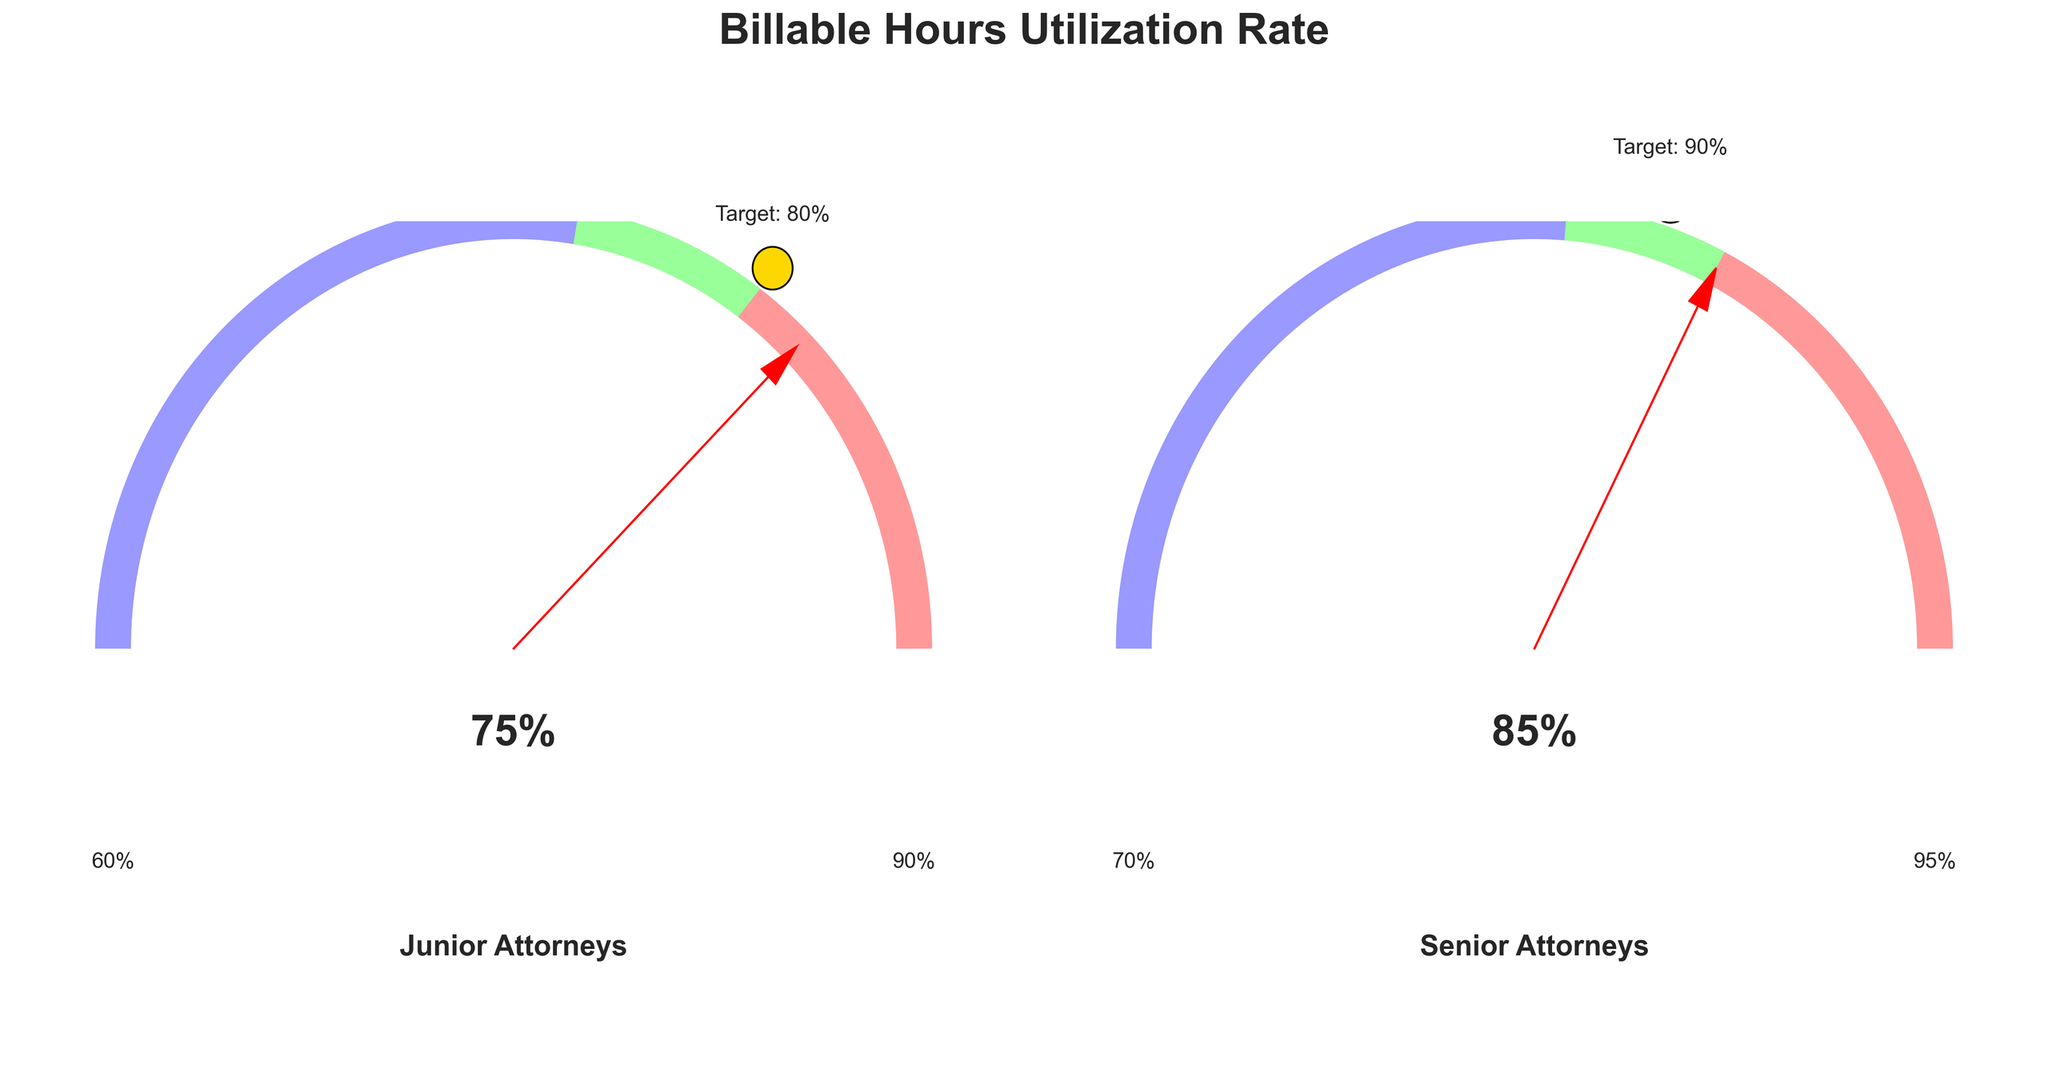What is the billable hours utilization rate for Junior Attorneys? The gauge chart shows the current rate for Junior Attorneys with a large red needle pointing to a percentage. This value is also displayed textually within the chart.
Answer: 75% What is the target rate for Senior Attorneys? The gauge chart for Senior Attorneys includes a circular marker labeled "Target" with the specific target rate displayed in gold color.
Answer: 90% Which group has a higher utilization rate, Junior or Senior Attorneys? By comparing the large red needles in both gauge charts, the Senior Attorneys' needle points to 85%, while the Junior Attorneys' needle points to 75%.
Answer: Senior Attorneys What is the difference between the current rate and the target rate for Junior Attorneys? Subtract the current rate of 75% from the target rate of 80%, both displayed in the gauge chart for Junior Attorneys.
Answer: 5% Does the current utilization rate for Junior Attorneys fall within their optimal range? The Junior Attorneys’ optimal range is indicated by the green section (60% to 90%). The current utilization rate is 75%, which is within this range.
Answer: Yes What is the low threshold for Senior Attorneys? The gauge chart for Senior Attorneys indicates the low threshold at the point where the red section of the arc ends. This is labeled at 70%.
Answer: 70% What is the difference between the high threshold values for Junior and Senior Attorneys? The high threshold for Junior Attorneys is 90%, and for Senior Attorneys is 95%. Subtract 90% from 95%.
Answer: 5% Which threshold segment is longer for Senior Attorneys: the low (red) or high (blue) one? The red segment ranges from 0% to 70%, and the blue segment ranges from 95% to 100%. Since the red segment spans more value percentages, it is longer.
Answer: Low threshold Do both groups exceed their respective low thresholds? The low thresholds are 60% for Junior Attorneys and 70% for Senior Attorneys. Both current rates, 75% and 85% respectively, are above their low thresholds.
Answer: Yes 